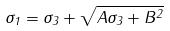<formula> <loc_0><loc_0><loc_500><loc_500>\sigma _ { 1 } = \sigma _ { 3 } + \sqrt { A \sigma _ { 3 } + B ^ { 2 } }</formula> 